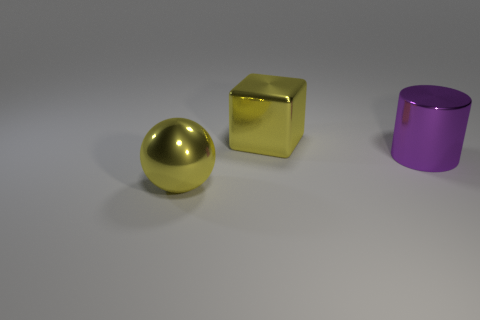Add 3 big blue metal cylinders. How many objects exist? 6 Subtract all cylinders. How many objects are left? 2 Add 2 big metallic objects. How many big metallic objects are left? 5 Add 1 large yellow metallic blocks. How many large yellow metallic blocks exist? 2 Subtract 0 brown cylinders. How many objects are left? 3 Subtract all big gray blocks. Subtract all spheres. How many objects are left? 2 